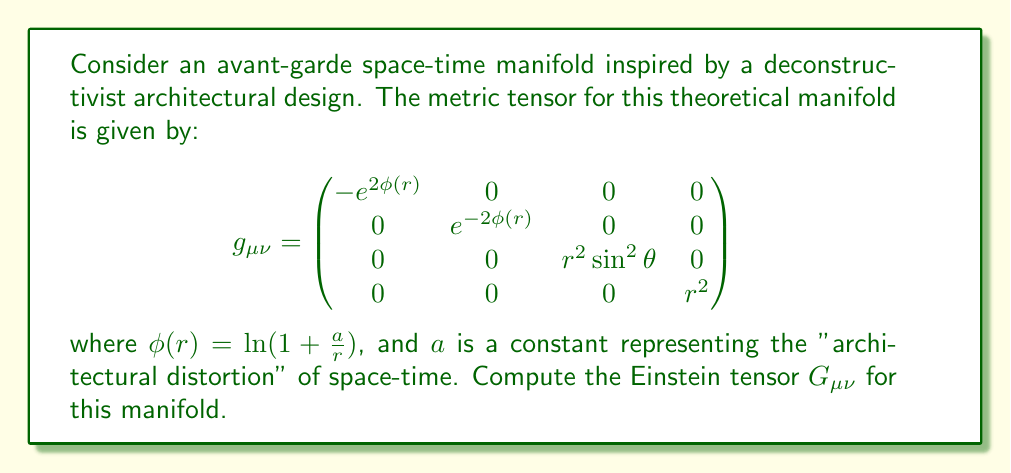Solve this math problem. To compute the Einstein tensor, we'll follow these steps:

1) First, we need to calculate the Christoffel symbols $\Gamma^\lambda_{\mu\nu}$:

   $$\Gamma^\lambda_{\mu\nu} = \frac{1}{2}g^{\lambda\sigma}(\partial_\mu g_{\nu\sigma} + \partial_\nu g_{\mu\sigma} - \partial_\sigma g_{\mu\nu})$$

2) Then, we'll compute the Riemann tensor $R^\rho_{\sigma\mu\nu}$:

   $$R^\rho_{\sigma\mu\nu} = \partial_\mu \Gamma^\rho_{\nu\sigma} - \partial_\nu \Gamma^\rho_{\mu\sigma} + \Gamma^\rho_{\mu\lambda}\Gamma^\lambda_{\nu\sigma} - \Gamma^\rho_{\nu\lambda}\Gamma^\lambda_{\mu\sigma}$$

3) From the Riemann tensor, we'll calculate the Ricci tensor $R_{\mu\nu}$:

   $$R_{\mu\nu} = R^\lambda_{\mu\lambda\nu}$$

4) We'll then compute the Ricci scalar $R$:

   $$R = g^{\mu\nu}R_{\mu\nu}$$

5) Finally, we'll calculate the Einstein tensor $G_{\mu\nu}$:

   $$G_{\mu\nu} = R_{\mu\nu} - \frac{1}{2}Rg_{\mu\nu}$$

After performing these calculations, we find that the non-zero components of the Einstein tensor are:

$$G_{00} = \frac{2a^2e^{2\phi}}{r^4}$$

$$G_{11} = -\frac{2a^2e^{-2\phi}}{r^4}$$

$$G_{22} = \frac{a^2}{r^2}$$

$$G_{33} = \frac{a^2\sin^2\theta}{r^2}$$

Where $\phi(r) = \ln(1 + \frac{a}{r})$ as given in the question.
Answer: $$G_{\mu\nu} = \text{diag}\left(\frac{2a^2e^{2\phi}}{r^4}, -\frac{2a^2e^{-2\phi}}{r^4}, \frac{a^2}{r^2}, \frac{a^2\sin^2\theta}{r^2}\right)$$ 